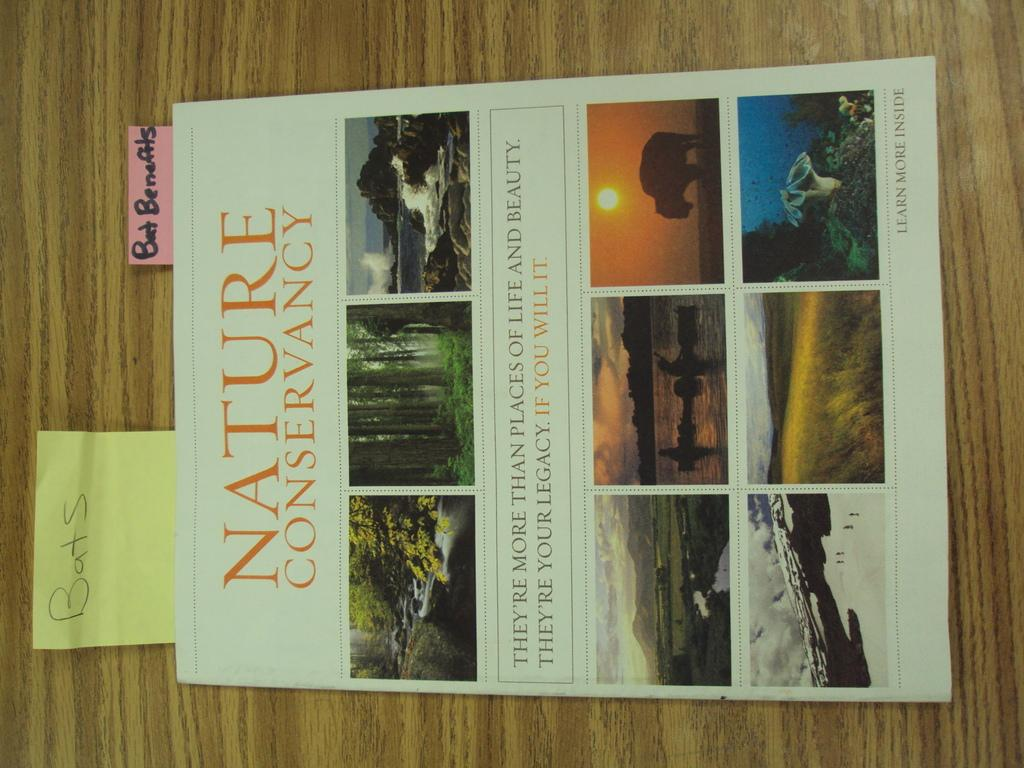What is the main subject in the center area of the image? There is a poster in the center area of the image. What can be found on the poster? The poster contains an image and text. Are there any additional items on the left side of the image? Yes, there are two small papers on the left side of the image. How does the crow interact with the poster in the image? There is no crow present in the image, so it cannot interact with the poster. 